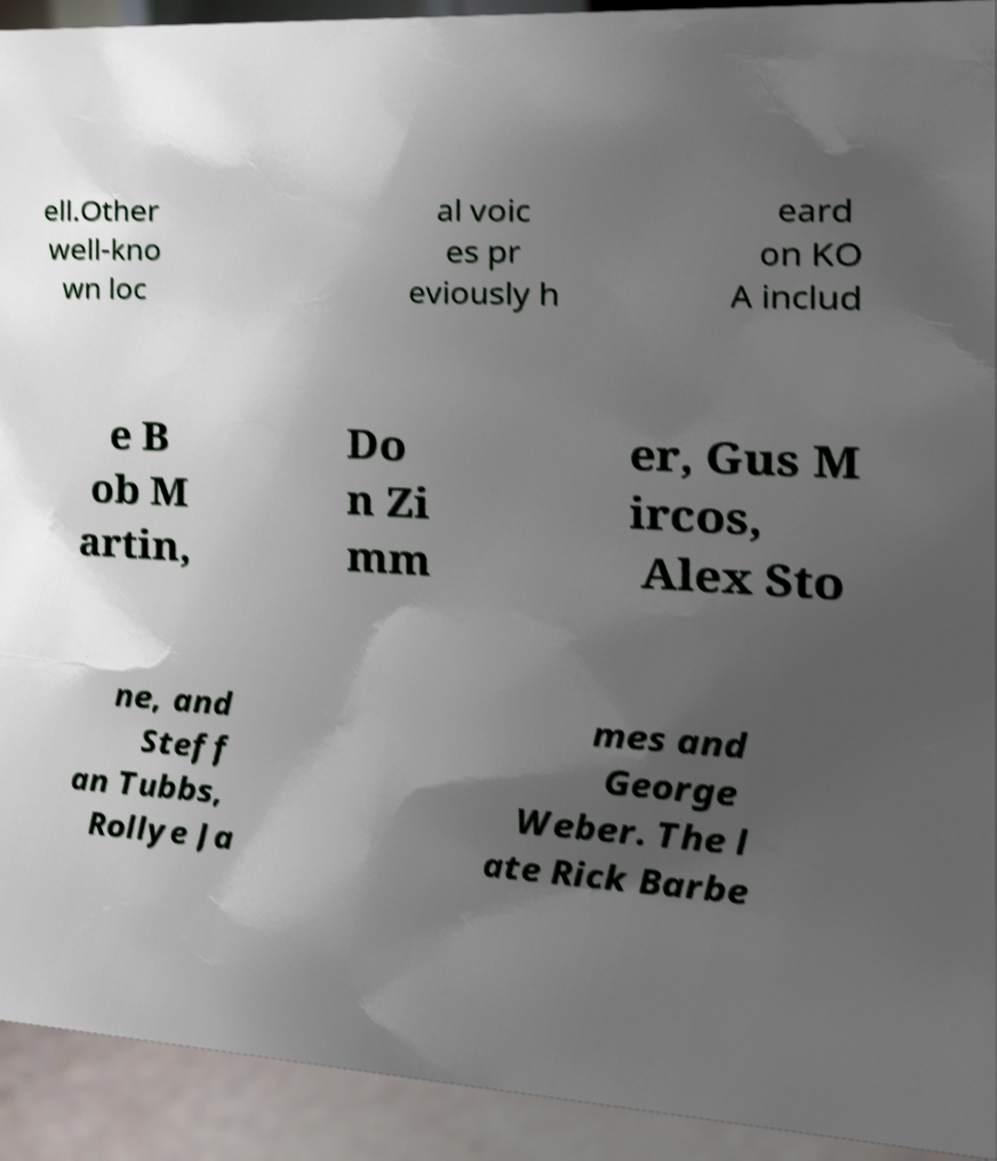Could you extract and type out the text from this image? ell.Other well-kno wn loc al voic es pr eviously h eard on KO A includ e B ob M artin, Do n Zi mm er, Gus M ircos, Alex Sto ne, and Steff an Tubbs, Rollye Ja mes and George Weber. The l ate Rick Barbe 